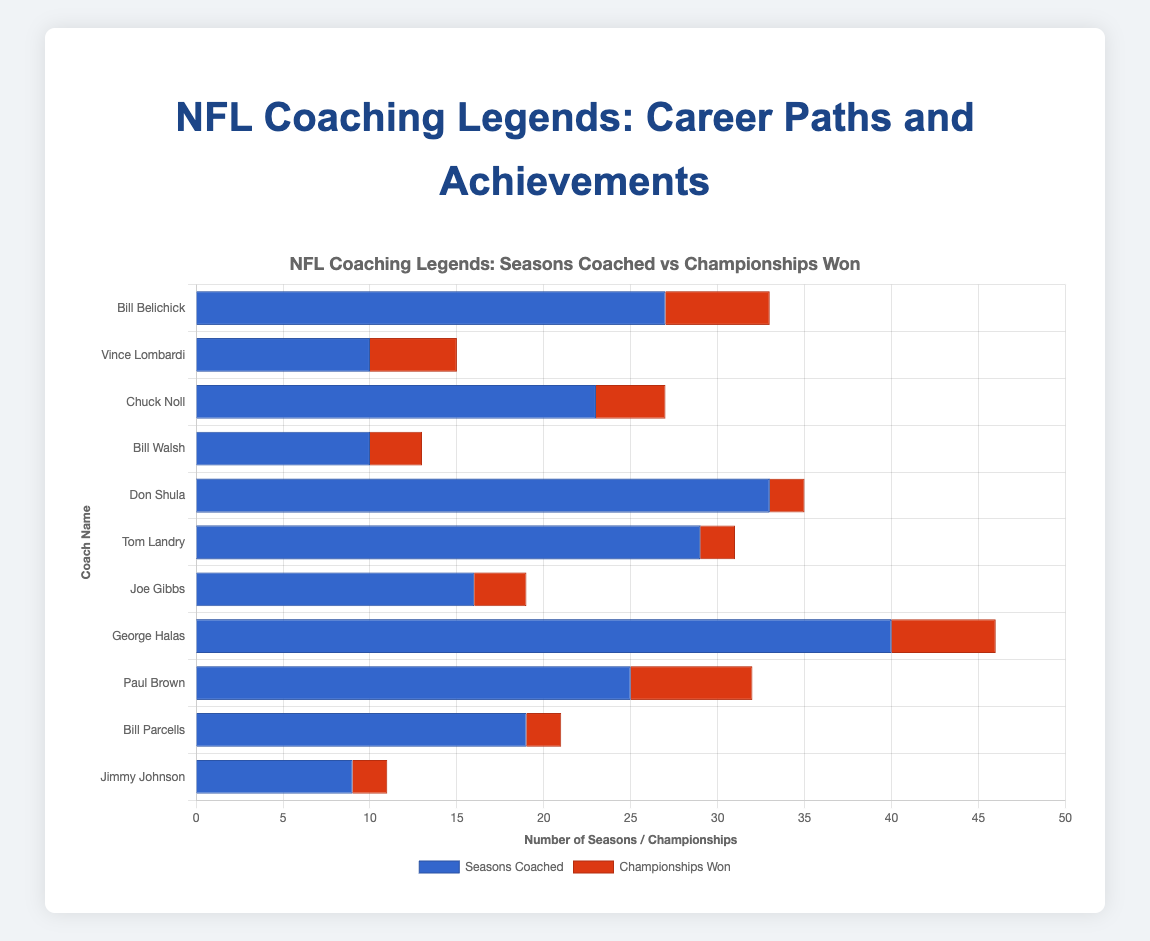Who coached the most seasons? George Halas coached the most seasons with 40.
Answer: George Halas Which coach won the most championships? Paul Brown won the most championships with 7.
Answer: Paul Brown How many seasons did Bill Belichick coach compared to Don Shula? Bill Belichick coached for 27 seasons, and Don Shula coached for 33 seasons.
Answer: 6 fewer seasons What is the difference in championships won between Vince Lombardi and Chuck Noll? Vince Lombardi won 5 championships, and Chuck Noll won 4 championships. The difference is 1.
Answer: 1 Among coaches with 2 championships, who had the longest career in terms of seasons coached? Don Shula coached for 33 seasons.
Answer: Don Shula What's the total number of seasons coached by George Halas and Paul Brown combined? George Halas coached 40 seasons, and Paul Brown coached 25 seasons. The total is 40 + 25 = 65.
Answer: 65 How many more championships did Bill Walsh win compared to Bill Parcells? Bill Walsh won 3 championships, and Bill Parcells won 2 championships. The difference is 3 - 2 = 1.
Answer: 1 How many coaches coached for more than 20 seasons? There are five coaches who coached more than 20 seasons: Bill Belichick, Chuck Noll, Don Shula, Tom Landry, and Paul Brown.
Answer: 5 What's the average number of seasons coached by the listed coaches? Sum of seasons coached: 27+10+23+10+33+29+16+40+25+19+9 = 241. Number of coaches: 11. Average = 241 / 11 ≈ 21.91.
Answer: 21.91 Which coach has the second highest number of championships? Bill Belichick and George Halas both have the second highest number of championships with 6 each.
Answer: Bill Belichick and George Halas 